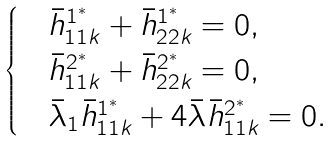Convert formula to latex. <formula><loc_0><loc_0><loc_500><loc_500>\begin{cases} & \bar { h } ^ { 1 ^ { * } } _ { 1 1 k } + \bar { h } ^ { 1 ^ { * } } _ { 2 2 k } = 0 , \\ & \bar { h } ^ { 2 ^ { * } } _ { 1 1 k } + \bar { h } ^ { 2 ^ { * } } _ { 2 2 k } = 0 , \\ & \bar { \lambda } _ { 1 } \bar { h } ^ { 1 ^ { \ast } } _ { 1 1 k } + 4 \bar { \lambda } \bar { h } ^ { 2 ^ { \ast } } _ { 1 1 k } = 0 . \end{cases}</formula> 